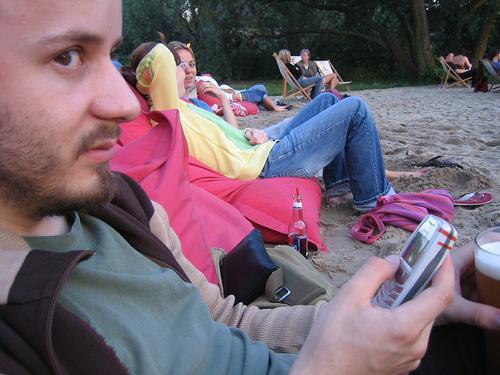How many people are having a conversation in the scene?
Give a very brief answer. 2. How many people are there?
Give a very brief answer. 2. How many handbags can you see?
Give a very brief answer. 2. 